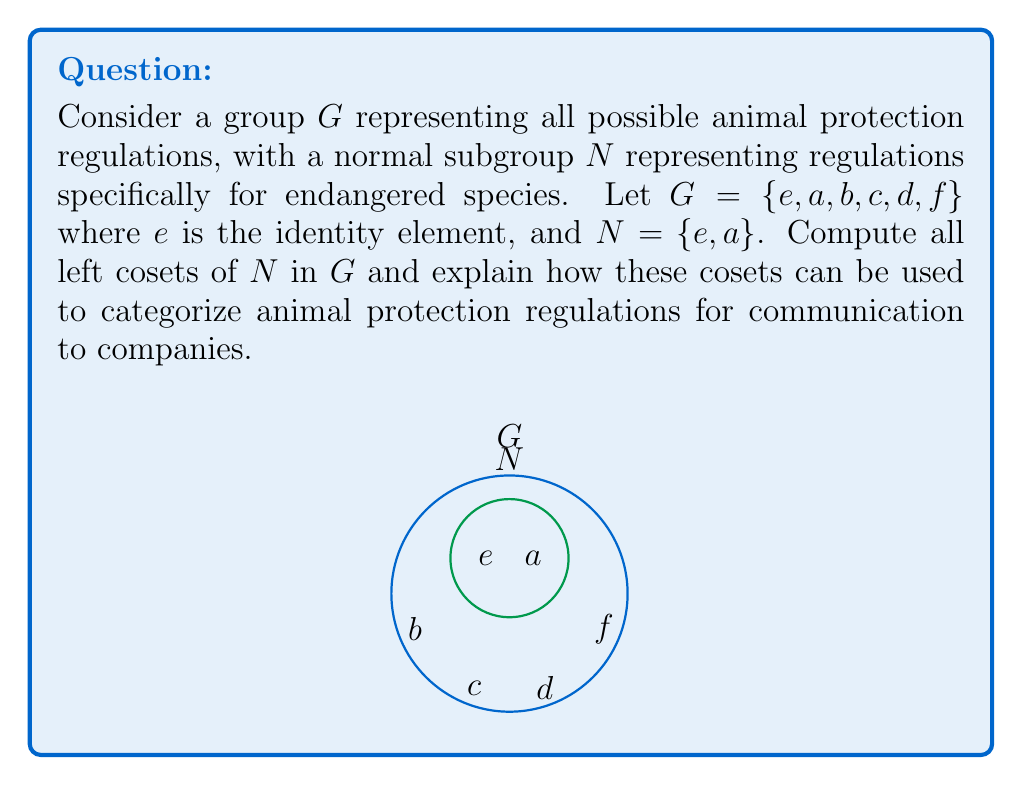Teach me how to tackle this problem. To compute the left cosets of $N$ in $G$, we need to multiply each element of $G$ by $N$ from the left:

1) First coset: $eN = \{ee, ea\} = \{e, a\} = N$

2) Second coset: $aN = \{ae, aa\} = \{a, e\} = N$

3) Third coset: $bN = \{be, ba\} = \{b, ba\}$

4) Fourth coset: $cN = \{ce, ca\} = \{c, ca\}$

5) Fifth coset: $dN = \{de, da\} = \{d, da\}$

6) Sixth coset: $fN = \{fe, fa\} = \{f, fa\}$

Since $N$ is a normal subgroup, left cosets are equal to right cosets. We can see that there are four distinct cosets:

$$G/N = \{N, bN, cN, dN\}$$

In the context of animal protection regulations:
- $N$ represents regulations for endangered species
- $bN$ could represent regulations for domesticated animals
- $cN$ could represent regulations for wildlife in captivity
- $dN$ could represent regulations for animals used in research

This categorization allows the animal rights lobbyist to efficiently communicate different sets of regulations to companies based on their specific involvement with animals. Each coset represents a distinct category of regulations, simplifying the process of explaining complex governmental requirements.
Answer: $G/N = \{N, bN, cN, dN\}$, where $N = \{e, a\}$, $bN = \{b, ba\}$, $cN = \{c, ca\}$, and $dN = \{d, da\}$. 